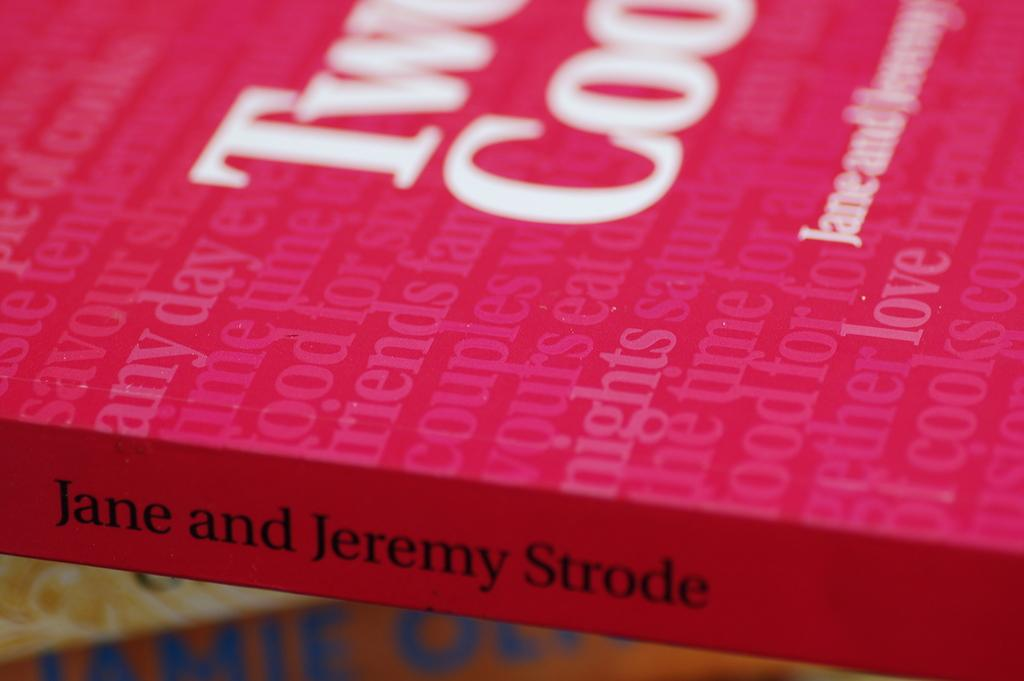<image>
Provide a brief description of the given image. A red book with pink and white lettering text by Jane and Jeremy Strode. 